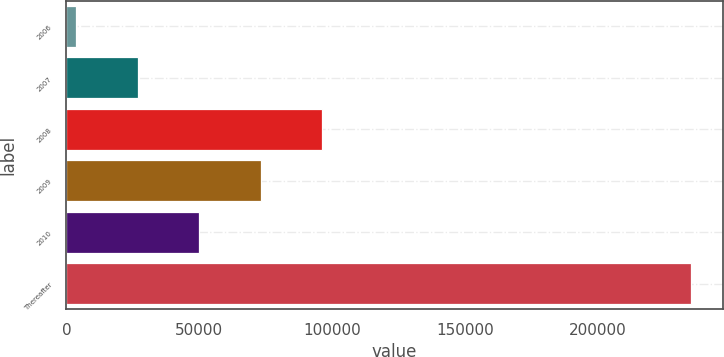<chart> <loc_0><loc_0><loc_500><loc_500><bar_chart><fcel>2006<fcel>2007<fcel>2008<fcel>2009<fcel>2010<fcel>Thereafter<nl><fcel>3649<fcel>26799.7<fcel>96251.8<fcel>73101.1<fcel>49950.4<fcel>235156<nl></chart> 